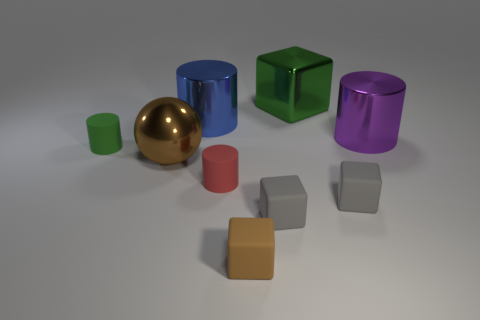Subtract all small cubes. How many cubes are left? 1 Add 1 tiny cylinders. How many objects exist? 10 Subtract all red cylinders. How many cylinders are left? 3 Subtract 3 cubes. How many cubes are left? 1 Subtract all balls. How many objects are left? 8 Subtract all yellow cylinders. Subtract all yellow blocks. How many cylinders are left? 4 Subtract all blue cylinders. How many purple balls are left? 0 Add 3 big blue shiny cylinders. How many big blue shiny cylinders are left? 4 Add 8 metal cylinders. How many metal cylinders exist? 10 Subtract 1 red cylinders. How many objects are left? 8 